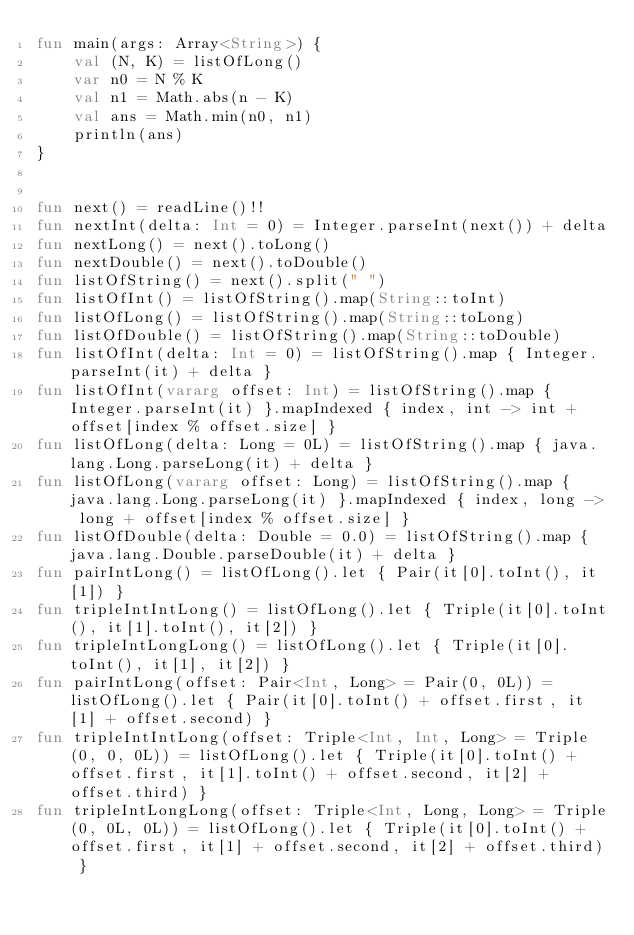<code> <loc_0><loc_0><loc_500><loc_500><_Kotlin_>fun main(args: Array<String>) {
    val (N, K) = listOfLong()
    var n0 = N % K
    val n1 = Math.abs(n - K)
    val ans = Math.min(n0, n1)
    println(ans)
}


fun next() = readLine()!!
fun nextInt(delta: Int = 0) = Integer.parseInt(next()) + delta
fun nextLong() = next().toLong()
fun nextDouble() = next().toDouble()
fun listOfString() = next().split(" ")
fun listOfInt() = listOfString().map(String::toInt)
fun listOfLong() = listOfString().map(String::toLong)
fun listOfDouble() = listOfString().map(String::toDouble)
fun listOfInt(delta: Int = 0) = listOfString().map { Integer.parseInt(it) + delta }
fun listOfInt(vararg offset: Int) = listOfString().map { Integer.parseInt(it) }.mapIndexed { index, int -> int + offset[index % offset.size] }
fun listOfLong(delta: Long = 0L) = listOfString().map { java.lang.Long.parseLong(it) + delta }
fun listOfLong(vararg offset: Long) = listOfString().map { java.lang.Long.parseLong(it) }.mapIndexed { index, long -> long + offset[index % offset.size] }
fun listOfDouble(delta: Double = 0.0) = listOfString().map { java.lang.Double.parseDouble(it) + delta }
fun pairIntLong() = listOfLong().let { Pair(it[0].toInt(), it[1]) }
fun tripleIntIntLong() = listOfLong().let { Triple(it[0].toInt(), it[1].toInt(), it[2]) }
fun tripleIntLongLong() = listOfLong().let { Triple(it[0].toInt(), it[1], it[2]) }
fun pairIntLong(offset: Pair<Int, Long> = Pair(0, 0L)) = listOfLong().let { Pair(it[0].toInt() + offset.first, it[1] + offset.second) }
fun tripleIntIntLong(offset: Triple<Int, Int, Long> = Triple(0, 0, 0L)) = listOfLong().let { Triple(it[0].toInt() + offset.first, it[1].toInt() + offset.second, it[2] + offset.third) }
fun tripleIntLongLong(offset: Triple<Int, Long, Long> = Triple(0, 0L, 0L)) = listOfLong().let { Triple(it[0].toInt() + offset.first, it[1] + offset.second, it[2] + offset.third) }



</code> 